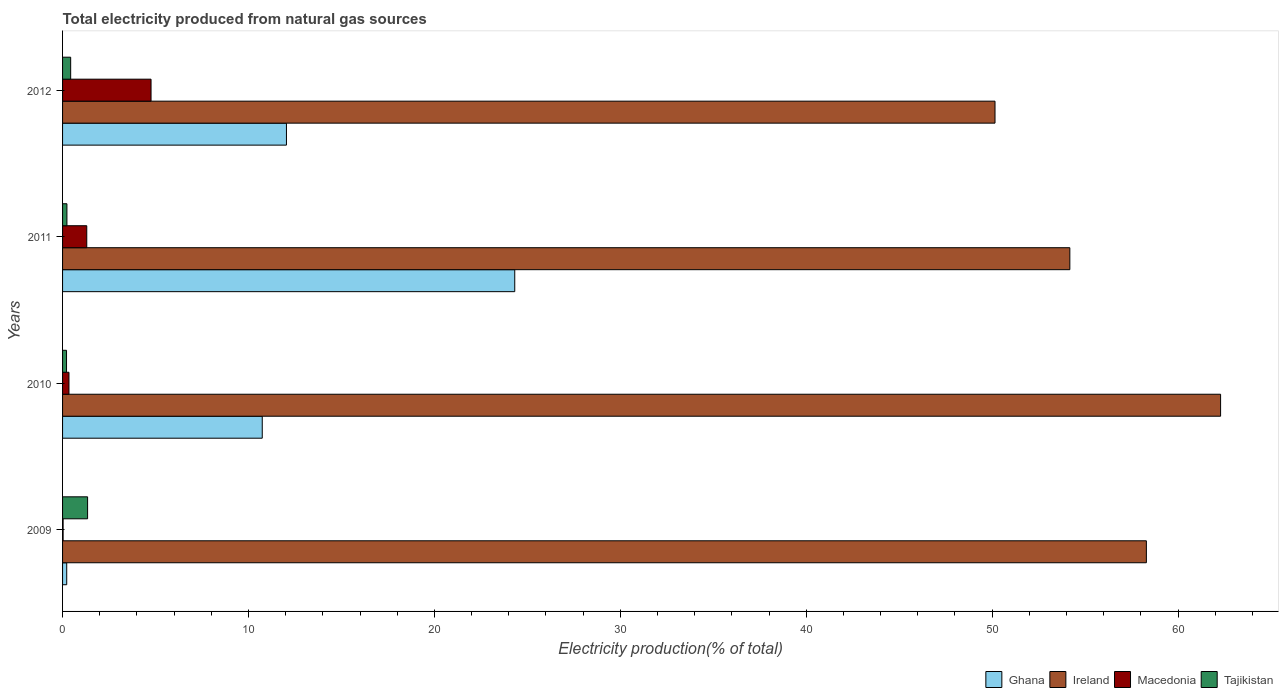How many groups of bars are there?
Provide a short and direct response. 4. Are the number of bars per tick equal to the number of legend labels?
Your answer should be compact. Yes. How many bars are there on the 4th tick from the bottom?
Keep it short and to the point. 4. In how many cases, is the number of bars for a given year not equal to the number of legend labels?
Give a very brief answer. 0. What is the total electricity produced in Ghana in 2012?
Your response must be concise. 12.04. Across all years, what is the maximum total electricity produced in Ghana?
Provide a succinct answer. 24.32. Across all years, what is the minimum total electricity produced in Ghana?
Your response must be concise. 0.22. In which year was the total electricity produced in Tajikistan minimum?
Provide a short and direct response. 2010. What is the total total electricity produced in Macedonia in the graph?
Give a very brief answer. 6.43. What is the difference between the total electricity produced in Macedonia in 2010 and that in 2012?
Offer a very short reply. -4.41. What is the difference between the total electricity produced in Tajikistan in 2009 and the total electricity produced in Macedonia in 2011?
Provide a succinct answer. 0.04. What is the average total electricity produced in Ghana per year?
Provide a succinct answer. 11.83. In the year 2010, what is the difference between the total electricity produced in Ireland and total electricity produced in Macedonia?
Provide a succinct answer. 61.94. In how many years, is the total electricity produced in Ghana greater than 54 %?
Offer a very short reply. 0. What is the ratio of the total electricity produced in Tajikistan in 2010 to that in 2012?
Make the answer very short. 0.49. Is the total electricity produced in Ghana in 2009 less than that in 2010?
Provide a succinct answer. Yes. Is the difference between the total electricity produced in Ireland in 2009 and 2012 greater than the difference between the total electricity produced in Macedonia in 2009 and 2012?
Provide a succinct answer. Yes. What is the difference between the highest and the second highest total electricity produced in Ghana?
Your answer should be compact. 12.28. What is the difference between the highest and the lowest total electricity produced in Macedonia?
Your answer should be very brief. 4.73. Is the sum of the total electricity produced in Ghana in 2010 and 2012 greater than the maximum total electricity produced in Macedonia across all years?
Your response must be concise. Yes. Is it the case that in every year, the sum of the total electricity produced in Ghana and total electricity produced in Macedonia is greater than the sum of total electricity produced in Ireland and total electricity produced in Tajikistan?
Your response must be concise. No. What does the 3rd bar from the top in 2010 represents?
Your response must be concise. Ireland. What does the 1st bar from the bottom in 2011 represents?
Keep it short and to the point. Ghana. Is it the case that in every year, the sum of the total electricity produced in Tajikistan and total electricity produced in Ghana is greater than the total electricity produced in Ireland?
Offer a terse response. No. Are all the bars in the graph horizontal?
Keep it short and to the point. Yes. What is the difference between two consecutive major ticks on the X-axis?
Offer a terse response. 10. How many legend labels are there?
Keep it short and to the point. 4. How are the legend labels stacked?
Offer a very short reply. Horizontal. What is the title of the graph?
Give a very brief answer. Total electricity produced from natural gas sources. Does "Equatorial Guinea" appear as one of the legend labels in the graph?
Give a very brief answer. No. What is the label or title of the Y-axis?
Keep it short and to the point. Years. What is the Electricity production(% of total) in Ghana in 2009?
Offer a very short reply. 0.22. What is the Electricity production(% of total) of Ireland in 2009?
Keep it short and to the point. 58.29. What is the Electricity production(% of total) in Macedonia in 2009?
Keep it short and to the point. 0.03. What is the Electricity production(% of total) of Tajikistan in 2009?
Provide a succinct answer. 1.35. What is the Electricity production(% of total) in Ghana in 2010?
Provide a succinct answer. 10.74. What is the Electricity production(% of total) in Ireland in 2010?
Provide a succinct answer. 62.29. What is the Electricity production(% of total) of Macedonia in 2010?
Ensure brevity in your answer.  0.34. What is the Electricity production(% of total) of Tajikistan in 2010?
Ensure brevity in your answer.  0.21. What is the Electricity production(% of total) in Ghana in 2011?
Give a very brief answer. 24.32. What is the Electricity production(% of total) in Ireland in 2011?
Your response must be concise. 54.18. What is the Electricity production(% of total) of Macedonia in 2011?
Provide a succinct answer. 1.3. What is the Electricity production(% of total) in Tajikistan in 2011?
Your response must be concise. 0.23. What is the Electricity production(% of total) of Ghana in 2012?
Your answer should be compact. 12.04. What is the Electricity production(% of total) in Ireland in 2012?
Your response must be concise. 50.15. What is the Electricity production(% of total) in Macedonia in 2012?
Your answer should be very brief. 4.76. What is the Electricity production(% of total) in Tajikistan in 2012?
Keep it short and to the point. 0.44. Across all years, what is the maximum Electricity production(% of total) of Ghana?
Your answer should be compact. 24.32. Across all years, what is the maximum Electricity production(% of total) in Ireland?
Make the answer very short. 62.29. Across all years, what is the maximum Electricity production(% of total) of Macedonia?
Offer a very short reply. 4.76. Across all years, what is the maximum Electricity production(% of total) of Tajikistan?
Give a very brief answer. 1.35. Across all years, what is the minimum Electricity production(% of total) in Ghana?
Make the answer very short. 0.22. Across all years, what is the minimum Electricity production(% of total) of Ireland?
Your answer should be compact. 50.15. Across all years, what is the minimum Electricity production(% of total) of Macedonia?
Offer a terse response. 0.03. Across all years, what is the minimum Electricity production(% of total) in Tajikistan?
Keep it short and to the point. 0.21. What is the total Electricity production(% of total) of Ghana in the graph?
Make the answer very short. 47.33. What is the total Electricity production(% of total) in Ireland in the graph?
Ensure brevity in your answer.  224.91. What is the total Electricity production(% of total) in Macedonia in the graph?
Give a very brief answer. 6.43. What is the total Electricity production(% of total) of Tajikistan in the graph?
Provide a succinct answer. 2.23. What is the difference between the Electricity production(% of total) in Ghana in 2009 and that in 2010?
Offer a very short reply. -10.52. What is the difference between the Electricity production(% of total) in Ireland in 2009 and that in 2010?
Offer a very short reply. -3.99. What is the difference between the Electricity production(% of total) in Macedonia in 2009 and that in 2010?
Give a very brief answer. -0.32. What is the difference between the Electricity production(% of total) in Tajikistan in 2009 and that in 2010?
Your answer should be very brief. 1.13. What is the difference between the Electricity production(% of total) in Ghana in 2009 and that in 2011?
Keep it short and to the point. -24.1. What is the difference between the Electricity production(% of total) of Ireland in 2009 and that in 2011?
Your answer should be very brief. 4.12. What is the difference between the Electricity production(% of total) in Macedonia in 2009 and that in 2011?
Provide a succinct answer. -1.27. What is the difference between the Electricity production(% of total) in Tajikistan in 2009 and that in 2011?
Your answer should be compact. 1.11. What is the difference between the Electricity production(% of total) of Ghana in 2009 and that in 2012?
Keep it short and to the point. -11.82. What is the difference between the Electricity production(% of total) of Ireland in 2009 and that in 2012?
Your answer should be very brief. 8.14. What is the difference between the Electricity production(% of total) of Macedonia in 2009 and that in 2012?
Offer a terse response. -4.73. What is the difference between the Electricity production(% of total) of Tajikistan in 2009 and that in 2012?
Offer a very short reply. 0.91. What is the difference between the Electricity production(% of total) in Ghana in 2010 and that in 2011?
Make the answer very short. -13.58. What is the difference between the Electricity production(% of total) of Ireland in 2010 and that in 2011?
Ensure brevity in your answer.  8.11. What is the difference between the Electricity production(% of total) in Macedonia in 2010 and that in 2011?
Your response must be concise. -0.96. What is the difference between the Electricity production(% of total) of Tajikistan in 2010 and that in 2011?
Provide a short and direct response. -0.02. What is the difference between the Electricity production(% of total) of Ghana in 2010 and that in 2012?
Offer a terse response. -1.3. What is the difference between the Electricity production(% of total) of Ireland in 2010 and that in 2012?
Your answer should be compact. 12.13. What is the difference between the Electricity production(% of total) of Macedonia in 2010 and that in 2012?
Ensure brevity in your answer.  -4.41. What is the difference between the Electricity production(% of total) of Tajikistan in 2010 and that in 2012?
Provide a short and direct response. -0.22. What is the difference between the Electricity production(% of total) in Ghana in 2011 and that in 2012?
Make the answer very short. 12.28. What is the difference between the Electricity production(% of total) of Ireland in 2011 and that in 2012?
Give a very brief answer. 4.03. What is the difference between the Electricity production(% of total) in Macedonia in 2011 and that in 2012?
Offer a very short reply. -3.46. What is the difference between the Electricity production(% of total) in Tajikistan in 2011 and that in 2012?
Your response must be concise. -0.2. What is the difference between the Electricity production(% of total) of Ghana in 2009 and the Electricity production(% of total) of Ireland in 2010?
Keep it short and to the point. -62.06. What is the difference between the Electricity production(% of total) in Ghana in 2009 and the Electricity production(% of total) in Macedonia in 2010?
Your answer should be compact. -0.12. What is the difference between the Electricity production(% of total) of Ghana in 2009 and the Electricity production(% of total) of Tajikistan in 2010?
Your answer should be compact. 0.01. What is the difference between the Electricity production(% of total) of Ireland in 2009 and the Electricity production(% of total) of Macedonia in 2010?
Provide a succinct answer. 57.95. What is the difference between the Electricity production(% of total) of Ireland in 2009 and the Electricity production(% of total) of Tajikistan in 2010?
Provide a short and direct response. 58.08. What is the difference between the Electricity production(% of total) of Macedonia in 2009 and the Electricity production(% of total) of Tajikistan in 2010?
Provide a succinct answer. -0.18. What is the difference between the Electricity production(% of total) in Ghana in 2009 and the Electricity production(% of total) in Ireland in 2011?
Your response must be concise. -53.96. What is the difference between the Electricity production(% of total) in Ghana in 2009 and the Electricity production(% of total) in Macedonia in 2011?
Your response must be concise. -1.08. What is the difference between the Electricity production(% of total) in Ghana in 2009 and the Electricity production(% of total) in Tajikistan in 2011?
Offer a terse response. -0.01. What is the difference between the Electricity production(% of total) of Ireland in 2009 and the Electricity production(% of total) of Macedonia in 2011?
Your answer should be very brief. 56.99. What is the difference between the Electricity production(% of total) in Ireland in 2009 and the Electricity production(% of total) in Tajikistan in 2011?
Your answer should be very brief. 58.06. What is the difference between the Electricity production(% of total) of Macedonia in 2009 and the Electricity production(% of total) of Tajikistan in 2011?
Ensure brevity in your answer.  -0.2. What is the difference between the Electricity production(% of total) in Ghana in 2009 and the Electricity production(% of total) in Ireland in 2012?
Provide a succinct answer. -49.93. What is the difference between the Electricity production(% of total) in Ghana in 2009 and the Electricity production(% of total) in Macedonia in 2012?
Provide a succinct answer. -4.54. What is the difference between the Electricity production(% of total) of Ghana in 2009 and the Electricity production(% of total) of Tajikistan in 2012?
Your answer should be very brief. -0.21. What is the difference between the Electricity production(% of total) of Ireland in 2009 and the Electricity production(% of total) of Macedonia in 2012?
Provide a succinct answer. 53.54. What is the difference between the Electricity production(% of total) of Ireland in 2009 and the Electricity production(% of total) of Tajikistan in 2012?
Make the answer very short. 57.86. What is the difference between the Electricity production(% of total) in Macedonia in 2009 and the Electricity production(% of total) in Tajikistan in 2012?
Your answer should be compact. -0.41. What is the difference between the Electricity production(% of total) of Ghana in 2010 and the Electricity production(% of total) of Ireland in 2011?
Keep it short and to the point. -43.44. What is the difference between the Electricity production(% of total) of Ghana in 2010 and the Electricity production(% of total) of Macedonia in 2011?
Offer a very short reply. 9.44. What is the difference between the Electricity production(% of total) in Ghana in 2010 and the Electricity production(% of total) in Tajikistan in 2011?
Your answer should be compact. 10.51. What is the difference between the Electricity production(% of total) in Ireland in 2010 and the Electricity production(% of total) in Macedonia in 2011?
Your answer should be compact. 60.98. What is the difference between the Electricity production(% of total) in Ireland in 2010 and the Electricity production(% of total) in Tajikistan in 2011?
Your answer should be very brief. 62.05. What is the difference between the Electricity production(% of total) in Macedonia in 2010 and the Electricity production(% of total) in Tajikistan in 2011?
Keep it short and to the point. 0.11. What is the difference between the Electricity production(% of total) in Ghana in 2010 and the Electricity production(% of total) in Ireland in 2012?
Give a very brief answer. -39.41. What is the difference between the Electricity production(% of total) in Ghana in 2010 and the Electricity production(% of total) in Macedonia in 2012?
Provide a short and direct response. 5.98. What is the difference between the Electricity production(% of total) of Ghana in 2010 and the Electricity production(% of total) of Tajikistan in 2012?
Make the answer very short. 10.3. What is the difference between the Electricity production(% of total) in Ireland in 2010 and the Electricity production(% of total) in Macedonia in 2012?
Give a very brief answer. 57.53. What is the difference between the Electricity production(% of total) of Ireland in 2010 and the Electricity production(% of total) of Tajikistan in 2012?
Your answer should be compact. 61.85. What is the difference between the Electricity production(% of total) in Macedonia in 2010 and the Electricity production(% of total) in Tajikistan in 2012?
Provide a succinct answer. -0.09. What is the difference between the Electricity production(% of total) in Ghana in 2011 and the Electricity production(% of total) in Ireland in 2012?
Provide a short and direct response. -25.83. What is the difference between the Electricity production(% of total) of Ghana in 2011 and the Electricity production(% of total) of Macedonia in 2012?
Provide a succinct answer. 19.56. What is the difference between the Electricity production(% of total) in Ghana in 2011 and the Electricity production(% of total) in Tajikistan in 2012?
Your answer should be very brief. 23.89. What is the difference between the Electricity production(% of total) in Ireland in 2011 and the Electricity production(% of total) in Macedonia in 2012?
Your answer should be compact. 49.42. What is the difference between the Electricity production(% of total) in Ireland in 2011 and the Electricity production(% of total) in Tajikistan in 2012?
Keep it short and to the point. 53.74. What is the difference between the Electricity production(% of total) in Macedonia in 2011 and the Electricity production(% of total) in Tajikistan in 2012?
Offer a terse response. 0.87. What is the average Electricity production(% of total) of Ghana per year?
Provide a succinct answer. 11.83. What is the average Electricity production(% of total) in Ireland per year?
Your answer should be very brief. 56.23. What is the average Electricity production(% of total) of Macedonia per year?
Offer a very short reply. 1.61. What is the average Electricity production(% of total) in Tajikistan per year?
Offer a terse response. 0.56. In the year 2009, what is the difference between the Electricity production(% of total) of Ghana and Electricity production(% of total) of Ireland?
Provide a short and direct response. -58.07. In the year 2009, what is the difference between the Electricity production(% of total) of Ghana and Electricity production(% of total) of Macedonia?
Your answer should be compact. 0.19. In the year 2009, what is the difference between the Electricity production(% of total) in Ghana and Electricity production(% of total) in Tajikistan?
Provide a short and direct response. -1.12. In the year 2009, what is the difference between the Electricity production(% of total) of Ireland and Electricity production(% of total) of Macedonia?
Ensure brevity in your answer.  58.27. In the year 2009, what is the difference between the Electricity production(% of total) of Ireland and Electricity production(% of total) of Tajikistan?
Ensure brevity in your answer.  56.95. In the year 2009, what is the difference between the Electricity production(% of total) in Macedonia and Electricity production(% of total) in Tajikistan?
Provide a succinct answer. -1.32. In the year 2010, what is the difference between the Electricity production(% of total) in Ghana and Electricity production(% of total) in Ireland?
Ensure brevity in your answer.  -51.55. In the year 2010, what is the difference between the Electricity production(% of total) in Ghana and Electricity production(% of total) in Macedonia?
Offer a terse response. 10.4. In the year 2010, what is the difference between the Electricity production(% of total) in Ghana and Electricity production(% of total) in Tajikistan?
Your answer should be very brief. 10.53. In the year 2010, what is the difference between the Electricity production(% of total) in Ireland and Electricity production(% of total) in Macedonia?
Keep it short and to the point. 61.94. In the year 2010, what is the difference between the Electricity production(% of total) of Ireland and Electricity production(% of total) of Tajikistan?
Your answer should be very brief. 62.07. In the year 2010, what is the difference between the Electricity production(% of total) in Macedonia and Electricity production(% of total) in Tajikistan?
Your answer should be compact. 0.13. In the year 2011, what is the difference between the Electricity production(% of total) in Ghana and Electricity production(% of total) in Ireland?
Your response must be concise. -29.86. In the year 2011, what is the difference between the Electricity production(% of total) of Ghana and Electricity production(% of total) of Macedonia?
Provide a short and direct response. 23.02. In the year 2011, what is the difference between the Electricity production(% of total) in Ghana and Electricity production(% of total) in Tajikistan?
Give a very brief answer. 24.09. In the year 2011, what is the difference between the Electricity production(% of total) in Ireland and Electricity production(% of total) in Macedonia?
Provide a short and direct response. 52.88. In the year 2011, what is the difference between the Electricity production(% of total) in Ireland and Electricity production(% of total) in Tajikistan?
Your answer should be very brief. 53.94. In the year 2011, what is the difference between the Electricity production(% of total) of Macedonia and Electricity production(% of total) of Tajikistan?
Offer a very short reply. 1.07. In the year 2012, what is the difference between the Electricity production(% of total) of Ghana and Electricity production(% of total) of Ireland?
Give a very brief answer. -38.11. In the year 2012, what is the difference between the Electricity production(% of total) of Ghana and Electricity production(% of total) of Macedonia?
Provide a short and direct response. 7.28. In the year 2012, what is the difference between the Electricity production(% of total) in Ghana and Electricity production(% of total) in Tajikistan?
Give a very brief answer. 11.61. In the year 2012, what is the difference between the Electricity production(% of total) of Ireland and Electricity production(% of total) of Macedonia?
Ensure brevity in your answer.  45.39. In the year 2012, what is the difference between the Electricity production(% of total) of Ireland and Electricity production(% of total) of Tajikistan?
Offer a terse response. 49.72. In the year 2012, what is the difference between the Electricity production(% of total) of Macedonia and Electricity production(% of total) of Tajikistan?
Make the answer very short. 4.32. What is the ratio of the Electricity production(% of total) of Ghana in 2009 to that in 2010?
Ensure brevity in your answer.  0.02. What is the ratio of the Electricity production(% of total) in Ireland in 2009 to that in 2010?
Provide a succinct answer. 0.94. What is the ratio of the Electricity production(% of total) in Macedonia in 2009 to that in 2010?
Your response must be concise. 0.09. What is the ratio of the Electricity production(% of total) in Tajikistan in 2009 to that in 2010?
Keep it short and to the point. 6.32. What is the ratio of the Electricity production(% of total) in Ghana in 2009 to that in 2011?
Your answer should be very brief. 0.01. What is the ratio of the Electricity production(% of total) of Ireland in 2009 to that in 2011?
Offer a very short reply. 1.08. What is the ratio of the Electricity production(% of total) of Macedonia in 2009 to that in 2011?
Ensure brevity in your answer.  0.02. What is the ratio of the Electricity production(% of total) of Tajikistan in 2009 to that in 2011?
Keep it short and to the point. 5.75. What is the ratio of the Electricity production(% of total) in Ghana in 2009 to that in 2012?
Offer a very short reply. 0.02. What is the ratio of the Electricity production(% of total) in Ireland in 2009 to that in 2012?
Ensure brevity in your answer.  1.16. What is the ratio of the Electricity production(% of total) of Macedonia in 2009 to that in 2012?
Give a very brief answer. 0.01. What is the ratio of the Electricity production(% of total) in Tajikistan in 2009 to that in 2012?
Your answer should be compact. 3.09. What is the ratio of the Electricity production(% of total) in Ghana in 2010 to that in 2011?
Make the answer very short. 0.44. What is the ratio of the Electricity production(% of total) in Ireland in 2010 to that in 2011?
Offer a terse response. 1.15. What is the ratio of the Electricity production(% of total) of Macedonia in 2010 to that in 2011?
Provide a short and direct response. 0.26. What is the ratio of the Electricity production(% of total) in Tajikistan in 2010 to that in 2011?
Your response must be concise. 0.91. What is the ratio of the Electricity production(% of total) in Ghana in 2010 to that in 2012?
Offer a terse response. 0.89. What is the ratio of the Electricity production(% of total) in Ireland in 2010 to that in 2012?
Your response must be concise. 1.24. What is the ratio of the Electricity production(% of total) of Macedonia in 2010 to that in 2012?
Provide a succinct answer. 0.07. What is the ratio of the Electricity production(% of total) in Tajikistan in 2010 to that in 2012?
Offer a very short reply. 0.49. What is the ratio of the Electricity production(% of total) in Ghana in 2011 to that in 2012?
Provide a succinct answer. 2.02. What is the ratio of the Electricity production(% of total) in Ireland in 2011 to that in 2012?
Your answer should be very brief. 1.08. What is the ratio of the Electricity production(% of total) of Macedonia in 2011 to that in 2012?
Provide a succinct answer. 0.27. What is the ratio of the Electricity production(% of total) in Tajikistan in 2011 to that in 2012?
Provide a short and direct response. 0.54. What is the difference between the highest and the second highest Electricity production(% of total) in Ghana?
Offer a terse response. 12.28. What is the difference between the highest and the second highest Electricity production(% of total) in Ireland?
Keep it short and to the point. 3.99. What is the difference between the highest and the second highest Electricity production(% of total) in Macedonia?
Your answer should be very brief. 3.46. What is the difference between the highest and the second highest Electricity production(% of total) in Tajikistan?
Give a very brief answer. 0.91. What is the difference between the highest and the lowest Electricity production(% of total) in Ghana?
Provide a succinct answer. 24.1. What is the difference between the highest and the lowest Electricity production(% of total) in Ireland?
Your response must be concise. 12.13. What is the difference between the highest and the lowest Electricity production(% of total) in Macedonia?
Ensure brevity in your answer.  4.73. What is the difference between the highest and the lowest Electricity production(% of total) of Tajikistan?
Ensure brevity in your answer.  1.13. 